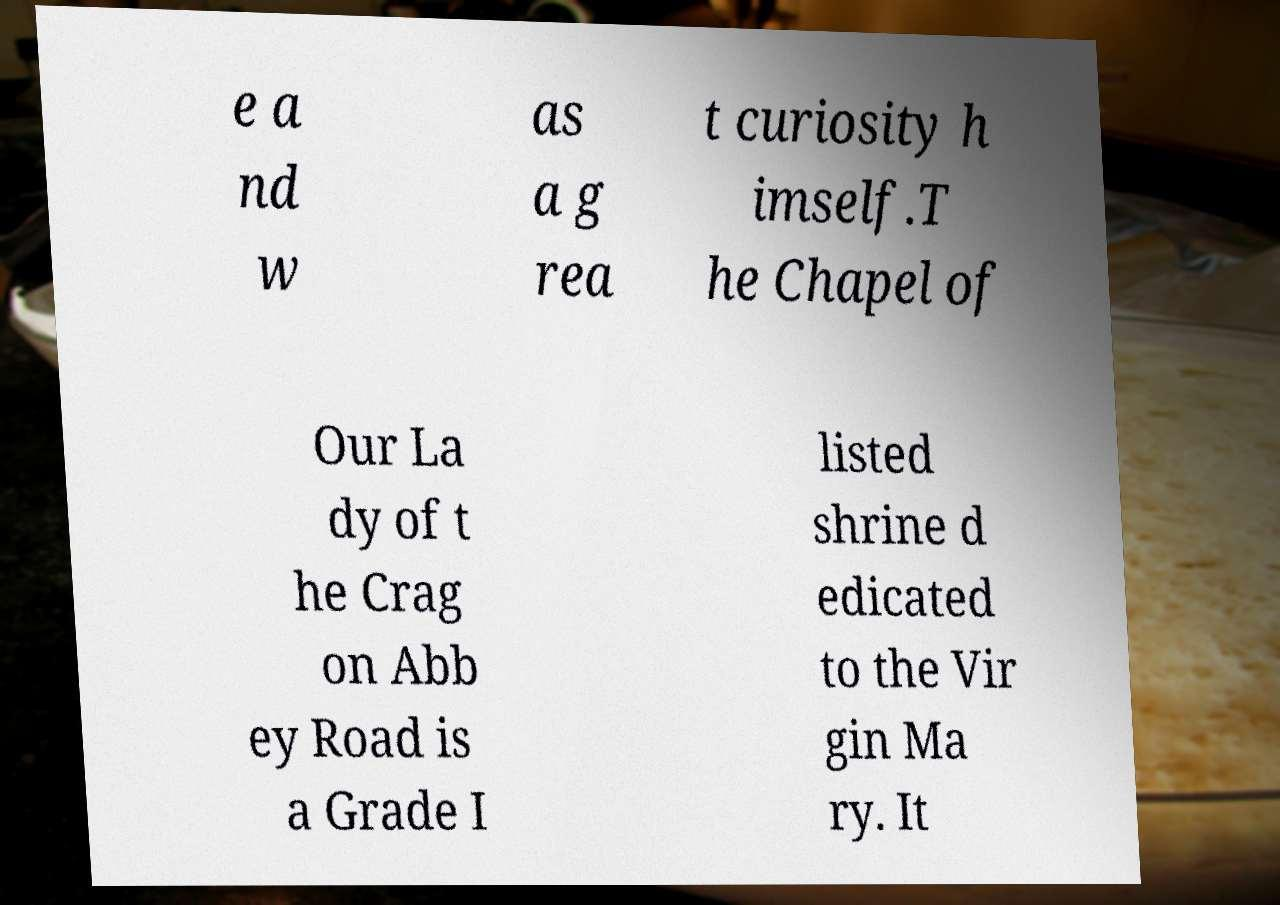I need the written content from this picture converted into text. Can you do that? e a nd w as a g rea t curiosity h imself.T he Chapel of Our La dy of t he Crag on Abb ey Road is a Grade I listed shrine d edicated to the Vir gin Ma ry. It 